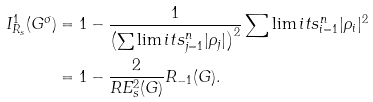<formula> <loc_0><loc_0><loc_500><loc_500>I ^ { 1 } _ { R _ { s } } ( G ^ { \sigma } ) & = 1 - \frac { 1 } { \left ( \sum \lim i t s _ { j = 1 } ^ { n } | \rho _ { j } | \right ) ^ { 2 } } \sum \lim i t s _ { i = 1 } ^ { n } | \rho _ { i } | ^ { 2 } \\ & = 1 - \frac { 2 } { R E _ { s } ^ { 2 } ( G ) } R _ { - 1 } ( G ) .</formula> 